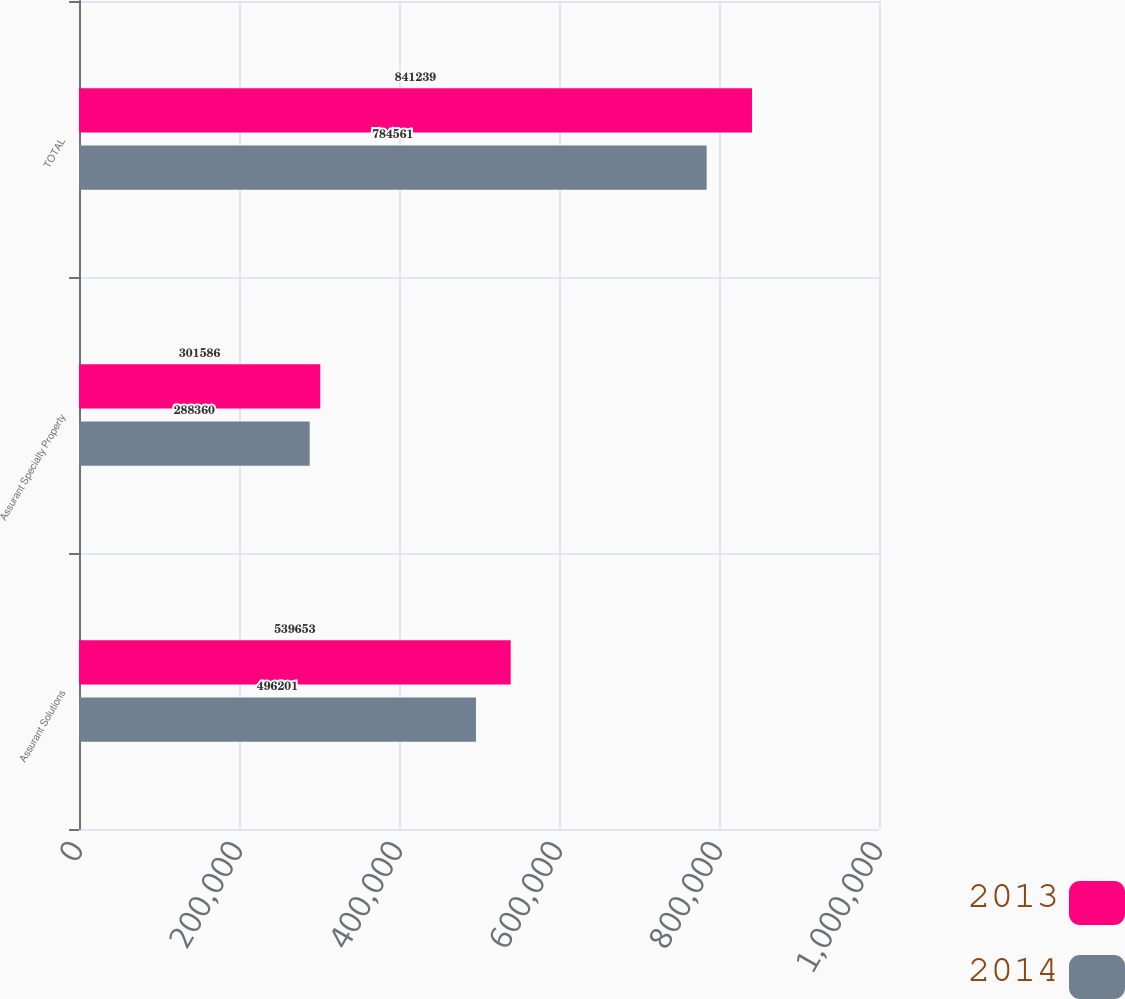Convert chart to OTSL. <chart><loc_0><loc_0><loc_500><loc_500><stacked_bar_chart><ecel><fcel>Assurant Solutions<fcel>Assurant Specialty Property<fcel>TOTAL<nl><fcel>2013<fcel>539653<fcel>301586<fcel>841239<nl><fcel>2014<fcel>496201<fcel>288360<fcel>784561<nl></chart> 